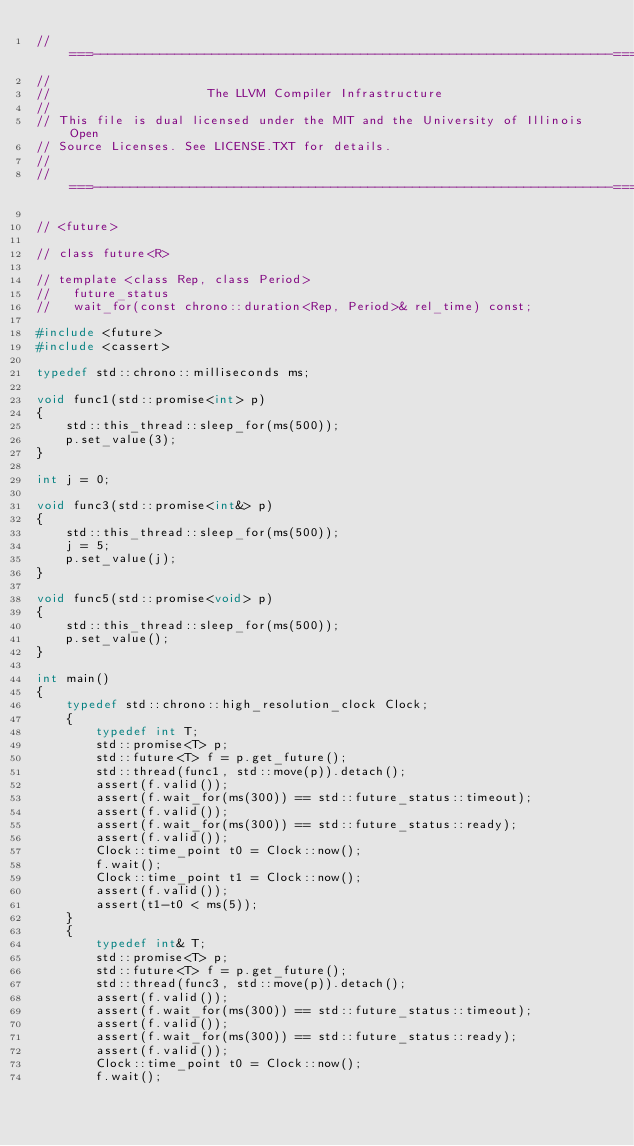Convert code to text. <code><loc_0><loc_0><loc_500><loc_500><_C++_>//===----------------------------------------------------------------------===//
//
//                     The LLVM Compiler Infrastructure
//
// This file is dual licensed under the MIT and the University of Illinois Open
// Source Licenses. See LICENSE.TXT for details.
//
//===----------------------------------------------------------------------===//

// <future>

// class future<R>

// template <class Rep, class Period>
//   future_status
//   wait_for(const chrono::duration<Rep, Period>& rel_time) const;

#include <future>
#include <cassert>

typedef std::chrono::milliseconds ms;

void func1(std::promise<int> p)
{
    std::this_thread::sleep_for(ms(500));
    p.set_value(3);
}

int j = 0;

void func3(std::promise<int&> p)
{
    std::this_thread::sleep_for(ms(500));
    j = 5;
    p.set_value(j);
}

void func5(std::promise<void> p)
{
    std::this_thread::sleep_for(ms(500));
    p.set_value();
}

int main()
{
    typedef std::chrono::high_resolution_clock Clock;
    {
        typedef int T;
        std::promise<T> p;
        std::future<T> f = p.get_future();
        std::thread(func1, std::move(p)).detach();
        assert(f.valid());
        assert(f.wait_for(ms(300)) == std::future_status::timeout);
        assert(f.valid());
        assert(f.wait_for(ms(300)) == std::future_status::ready);
        assert(f.valid());
        Clock::time_point t0 = Clock::now();
        f.wait();
        Clock::time_point t1 = Clock::now();
        assert(f.valid());
        assert(t1-t0 < ms(5));
    }
    {
        typedef int& T;
        std::promise<T> p;
        std::future<T> f = p.get_future();
        std::thread(func3, std::move(p)).detach();
        assert(f.valid());
        assert(f.wait_for(ms(300)) == std::future_status::timeout);
        assert(f.valid());
        assert(f.wait_for(ms(300)) == std::future_status::ready);
        assert(f.valid());
        Clock::time_point t0 = Clock::now();
        f.wait();</code> 